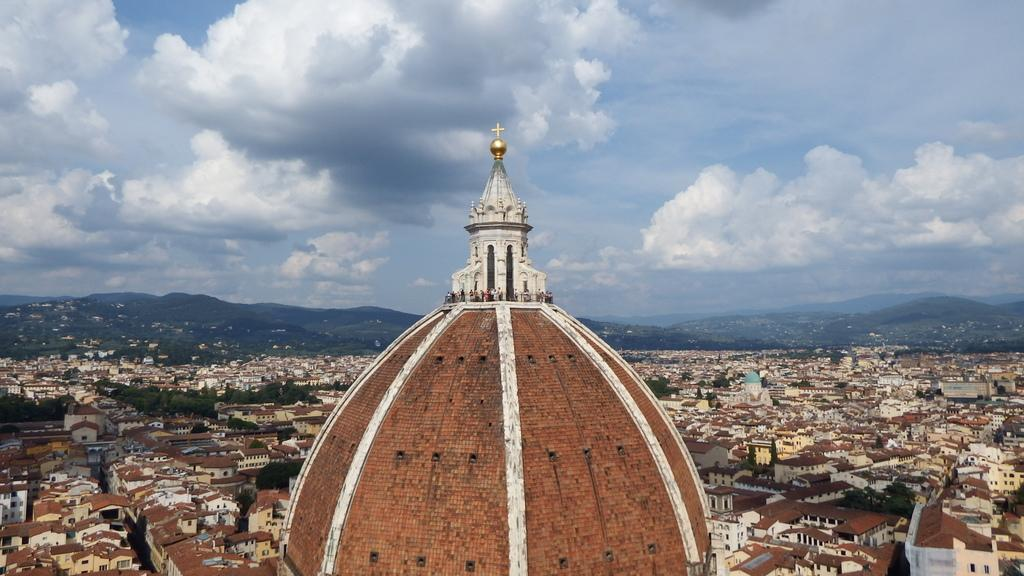What is the main subject of the image? The top of a building is visible in the image. What are the people on the building doing? There are people standing on the building. What can be seen in the background of the image? Other buildings, trees, mountains, and the sky are visible in the background of the image. Where is the shelf located in the image? There is no shelf present in the image. Is there a fight happening on the building in the image? There is no indication of a fight in the image; the people are simply standing on the building. 